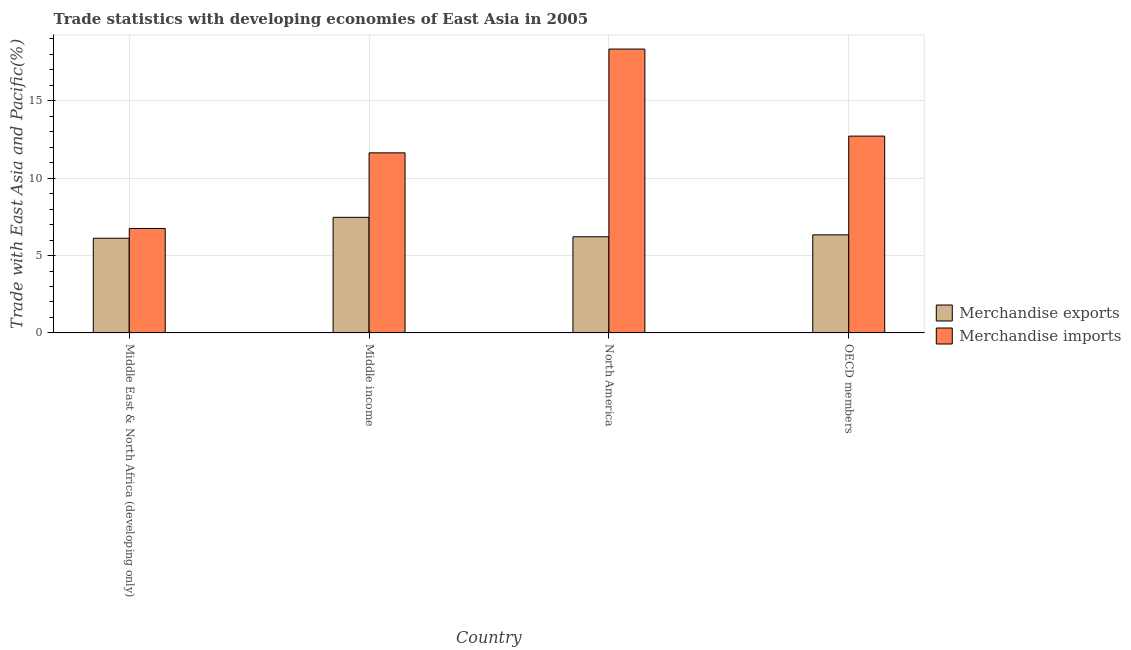How many groups of bars are there?
Your answer should be compact. 4. Are the number of bars per tick equal to the number of legend labels?
Your answer should be very brief. Yes. Are the number of bars on each tick of the X-axis equal?
Ensure brevity in your answer.  Yes. What is the label of the 1st group of bars from the left?
Offer a terse response. Middle East & North Africa (developing only). What is the merchandise exports in Middle East & North Africa (developing only)?
Offer a very short reply. 6.12. Across all countries, what is the maximum merchandise imports?
Give a very brief answer. 18.33. Across all countries, what is the minimum merchandise imports?
Provide a succinct answer. 6.75. In which country was the merchandise imports maximum?
Provide a short and direct response. North America. In which country was the merchandise exports minimum?
Offer a very short reply. Middle East & North Africa (developing only). What is the total merchandise imports in the graph?
Offer a terse response. 49.43. What is the difference between the merchandise imports in North America and that in OECD members?
Provide a succinct answer. 5.62. What is the difference between the merchandise imports in OECD members and the merchandise exports in North America?
Provide a short and direct response. 6.5. What is the average merchandise imports per country?
Ensure brevity in your answer.  12.36. What is the difference between the merchandise imports and merchandise exports in North America?
Provide a succinct answer. 12.12. In how many countries, is the merchandise exports greater than 9 %?
Make the answer very short. 0. What is the ratio of the merchandise exports in Middle East & North Africa (developing only) to that in OECD members?
Provide a short and direct response. 0.97. Is the merchandise imports in Middle income less than that in OECD members?
Provide a short and direct response. Yes. Is the difference between the merchandise imports in Middle East & North Africa (developing only) and OECD members greater than the difference between the merchandise exports in Middle East & North Africa (developing only) and OECD members?
Offer a very short reply. No. What is the difference between the highest and the second highest merchandise imports?
Ensure brevity in your answer.  5.62. What is the difference between the highest and the lowest merchandise imports?
Keep it short and to the point. 11.59. In how many countries, is the merchandise imports greater than the average merchandise imports taken over all countries?
Offer a terse response. 2. How many countries are there in the graph?
Ensure brevity in your answer.  4. What is the difference between two consecutive major ticks on the Y-axis?
Offer a very short reply. 5. Where does the legend appear in the graph?
Make the answer very short. Center right. How many legend labels are there?
Provide a short and direct response. 2. What is the title of the graph?
Your answer should be compact. Trade statistics with developing economies of East Asia in 2005. What is the label or title of the Y-axis?
Your answer should be compact. Trade with East Asia and Pacific(%). What is the Trade with East Asia and Pacific(%) of Merchandise exports in Middle East & North Africa (developing only)?
Ensure brevity in your answer.  6.12. What is the Trade with East Asia and Pacific(%) in Merchandise imports in Middle East & North Africa (developing only)?
Make the answer very short. 6.75. What is the Trade with East Asia and Pacific(%) in Merchandise exports in Middle income?
Make the answer very short. 7.47. What is the Trade with East Asia and Pacific(%) in Merchandise imports in Middle income?
Your response must be concise. 11.63. What is the Trade with East Asia and Pacific(%) in Merchandise exports in North America?
Make the answer very short. 6.21. What is the Trade with East Asia and Pacific(%) of Merchandise imports in North America?
Your answer should be very brief. 18.33. What is the Trade with East Asia and Pacific(%) in Merchandise exports in OECD members?
Provide a succinct answer. 6.34. What is the Trade with East Asia and Pacific(%) in Merchandise imports in OECD members?
Offer a very short reply. 12.71. Across all countries, what is the maximum Trade with East Asia and Pacific(%) in Merchandise exports?
Keep it short and to the point. 7.47. Across all countries, what is the maximum Trade with East Asia and Pacific(%) in Merchandise imports?
Provide a short and direct response. 18.33. Across all countries, what is the minimum Trade with East Asia and Pacific(%) of Merchandise exports?
Ensure brevity in your answer.  6.12. Across all countries, what is the minimum Trade with East Asia and Pacific(%) in Merchandise imports?
Your answer should be compact. 6.75. What is the total Trade with East Asia and Pacific(%) in Merchandise exports in the graph?
Ensure brevity in your answer.  26.13. What is the total Trade with East Asia and Pacific(%) in Merchandise imports in the graph?
Make the answer very short. 49.43. What is the difference between the Trade with East Asia and Pacific(%) of Merchandise exports in Middle East & North Africa (developing only) and that in Middle income?
Your response must be concise. -1.35. What is the difference between the Trade with East Asia and Pacific(%) in Merchandise imports in Middle East & North Africa (developing only) and that in Middle income?
Keep it short and to the point. -4.88. What is the difference between the Trade with East Asia and Pacific(%) in Merchandise exports in Middle East & North Africa (developing only) and that in North America?
Make the answer very short. -0.09. What is the difference between the Trade with East Asia and Pacific(%) of Merchandise imports in Middle East & North Africa (developing only) and that in North America?
Offer a very short reply. -11.59. What is the difference between the Trade with East Asia and Pacific(%) in Merchandise exports in Middle East & North Africa (developing only) and that in OECD members?
Your answer should be very brief. -0.22. What is the difference between the Trade with East Asia and Pacific(%) in Merchandise imports in Middle East & North Africa (developing only) and that in OECD members?
Make the answer very short. -5.96. What is the difference between the Trade with East Asia and Pacific(%) in Merchandise exports in Middle income and that in North America?
Your response must be concise. 1.25. What is the difference between the Trade with East Asia and Pacific(%) of Merchandise imports in Middle income and that in North America?
Give a very brief answer. -6.7. What is the difference between the Trade with East Asia and Pacific(%) in Merchandise exports in Middle income and that in OECD members?
Offer a very short reply. 1.13. What is the difference between the Trade with East Asia and Pacific(%) in Merchandise imports in Middle income and that in OECD members?
Ensure brevity in your answer.  -1.08. What is the difference between the Trade with East Asia and Pacific(%) of Merchandise exports in North America and that in OECD members?
Offer a terse response. -0.13. What is the difference between the Trade with East Asia and Pacific(%) of Merchandise imports in North America and that in OECD members?
Give a very brief answer. 5.62. What is the difference between the Trade with East Asia and Pacific(%) in Merchandise exports in Middle East & North Africa (developing only) and the Trade with East Asia and Pacific(%) in Merchandise imports in Middle income?
Make the answer very short. -5.51. What is the difference between the Trade with East Asia and Pacific(%) of Merchandise exports in Middle East & North Africa (developing only) and the Trade with East Asia and Pacific(%) of Merchandise imports in North America?
Provide a short and direct response. -12.22. What is the difference between the Trade with East Asia and Pacific(%) in Merchandise exports in Middle East & North Africa (developing only) and the Trade with East Asia and Pacific(%) in Merchandise imports in OECD members?
Your answer should be compact. -6.59. What is the difference between the Trade with East Asia and Pacific(%) in Merchandise exports in Middle income and the Trade with East Asia and Pacific(%) in Merchandise imports in North America?
Make the answer very short. -10.87. What is the difference between the Trade with East Asia and Pacific(%) in Merchandise exports in Middle income and the Trade with East Asia and Pacific(%) in Merchandise imports in OECD members?
Your answer should be compact. -5.25. What is the difference between the Trade with East Asia and Pacific(%) of Merchandise exports in North America and the Trade with East Asia and Pacific(%) of Merchandise imports in OECD members?
Provide a short and direct response. -6.5. What is the average Trade with East Asia and Pacific(%) in Merchandise exports per country?
Your answer should be very brief. 6.53. What is the average Trade with East Asia and Pacific(%) of Merchandise imports per country?
Give a very brief answer. 12.36. What is the difference between the Trade with East Asia and Pacific(%) of Merchandise exports and Trade with East Asia and Pacific(%) of Merchandise imports in Middle East & North Africa (developing only)?
Ensure brevity in your answer.  -0.63. What is the difference between the Trade with East Asia and Pacific(%) in Merchandise exports and Trade with East Asia and Pacific(%) in Merchandise imports in Middle income?
Keep it short and to the point. -4.17. What is the difference between the Trade with East Asia and Pacific(%) in Merchandise exports and Trade with East Asia and Pacific(%) in Merchandise imports in North America?
Keep it short and to the point. -12.12. What is the difference between the Trade with East Asia and Pacific(%) in Merchandise exports and Trade with East Asia and Pacific(%) in Merchandise imports in OECD members?
Give a very brief answer. -6.38. What is the ratio of the Trade with East Asia and Pacific(%) of Merchandise exports in Middle East & North Africa (developing only) to that in Middle income?
Provide a short and direct response. 0.82. What is the ratio of the Trade with East Asia and Pacific(%) of Merchandise imports in Middle East & North Africa (developing only) to that in Middle income?
Offer a very short reply. 0.58. What is the ratio of the Trade with East Asia and Pacific(%) of Merchandise exports in Middle East & North Africa (developing only) to that in North America?
Provide a short and direct response. 0.98. What is the ratio of the Trade with East Asia and Pacific(%) of Merchandise imports in Middle East & North Africa (developing only) to that in North America?
Ensure brevity in your answer.  0.37. What is the ratio of the Trade with East Asia and Pacific(%) in Merchandise exports in Middle East & North Africa (developing only) to that in OECD members?
Keep it short and to the point. 0.97. What is the ratio of the Trade with East Asia and Pacific(%) in Merchandise imports in Middle East & North Africa (developing only) to that in OECD members?
Make the answer very short. 0.53. What is the ratio of the Trade with East Asia and Pacific(%) in Merchandise exports in Middle income to that in North America?
Provide a succinct answer. 1.2. What is the ratio of the Trade with East Asia and Pacific(%) in Merchandise imports in Middle income to that in North America?
Provide a succinct answer. 0.63. What is the ratio of the Trade with East Asia and Pacific(%) in Merchandise exports in Middle income to that in OECD members?
Ensure brevity in your answer.  1.18. What is the ratio of the Trade with East Asia and Pacific(%) of Merchandise imports in Middle income to that in OECD members?
Give a very brief answer. 0.92. What is the ratio of the Trade with East Asia and Pacific(%) of Merchandise exports in North America to that in OECD members?
Keep it short and to the point. 0.98. What is the ratio of the Trade with East Asia and Pacific(%) in Merchandise imports in North America to that in OECD members?
Offer a very short reply. 1.44. What is the difference between the highest and the second highest Trade with East Asia and Pacific(%) of Merchandise exports?
Offer a very short reply. 1.13. What is the difference between the highest and the second highest Trade with East Asia and Pacific(%) in Merchandise imports?
Your answer should be very brief. 5.62. What is the difference between the highest and the lowest Trade with East Asia and Pacific(%) of Merchandise exports?
Keep it short and to the point. 1.35. What is the difference between the highest and the lowest Trade with East Asia and Pacific(%) of Merchandise imports?
Give a very brief answer. 11.59. 